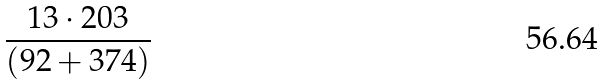Convert formula to latex. <formula><loc_0><loc_0><loc_500><loc_500>\frac { 1 3 \cdot 2 0 3 } { ( 9 2 + 3 7 4 ) }</formula> 